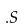Convert formula to latex. <formula><loc_0><loc_0><loc_500><loc_500>. S</formula> 